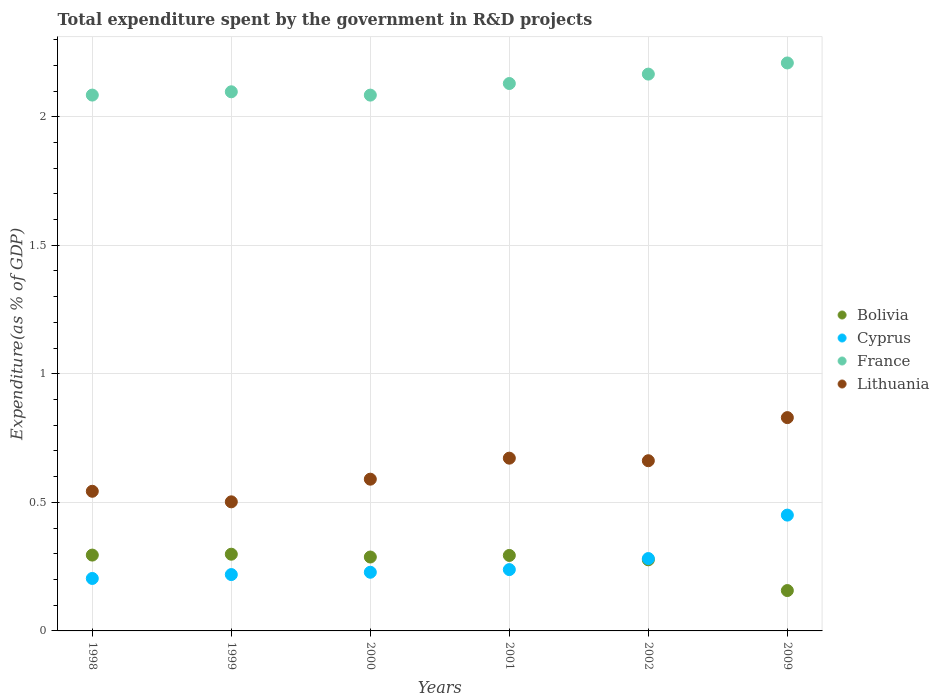Is the number of dotlines equal to the number of legend labels?
Your response must be concise. Yes. What is the total expenditure spent by the government in R&D projects in Bolivia in 2001?
Provide a succinct answer. 0.29. Across all years, what is the maximum total expenditure spent by the government in R&D projects in Bolivia?
Ensure brevity in your answer.  0.3. Across all years, what is the minimum total expenditure spent by the government in R&D projects in Lithuania?
Your answer should be compact. 0.5. What is the total total expenditure spent by the government in R&D projects in France in the graph?
Make the answer very short. 12.77. What is the difference between the total expenditure spent by the government in R&D projects in France in 1999 and that in 2002?
Provide a succinct answer. -0.07. What is the difference between the total expenditure spent by the government in R&D projects in Bolivia in 2001 and the total expenditure spent by the government in R&D projects in Lithuania in 2009?
Offer a terse response. -0.54. What is the average total expenditure spent by the government in R&D projects in France per year?
Provide a succinct answer. 2.13. In the year 1999, what is the difference between the total expenditure spent by the government in R&D projects in France and total expenditure spent by the government in R&D projects in Bolivia?
Make the answer very short. 1.8. What is the ratio of the total expenditure spent by the government in R&D projects in Lithuania in 1998 to that in 2000?
Keep it short and to the point. 0.92. Is the total expenditure spent by the government in R&D projects in Lithuania in 1999 less than that in 2001?
Your answer should be very brief. Yes. What is the difference between the highest and the second highest total expenditure spent by the government in R&D projects in Lithuania?
Your answer should be compact. 0.16. What is the difference between the highest and the lowest total expenditure spent by the government in R&D projects in Cyprus?
Provide a succinct answer. 0.25. In how many years, is the total expenditure spent by the government in R&D projects in France greater than the average total expenditure spent by the government in R&D projects in France taken over all years?
Keep it short and to the point. 3. Is the sum of the total expenditure spent by the government in R&D projects in Bolivia in 1998 and 2000 greater than the maximum total expenditure spent by the government in R&D projects in Cyprus across all years?
Provide a short and direct response. Yes. Is it the case that in every year, the sum of the total expenditure spent by the government in R&D projects in Cyprus and total expenditure spent by the government in R&D projects in Lithuania  is greater than the sum of total expenditure spent by the government in R&D projects in France and total expenditure spent by the government in R&D projects in Bolivia?
Give a very brief answer. Yes. Is the total expenditure spent by the government in R&D projects in Lithuania strictly less than the total expenditure spent by the government in R&D projects in Bolivia over the years?
Your response must be concise. No. How many years are there in the graph?
Keep it short and to the point. 6. What is the difference between two consecutive major ticks on the Y-axis?
Keep it short and to the point. 0.5. Does the graph contain any zero values?
Your answer should be compact. No. Does the graph contain grids?
Your answer should be compact. Yes. Where does the legend appear in the graph?
Offer a very short reply. Center right. What is the title of the graph?
Your answer should be very brief. Total expenditure spent by the government in R&D projects. What is the label or title of the X-axis?
Make the answer very short. Years. What is the label or title of the Y-axis?
Give a very brief answer. Expenditure(as % of GDP). What is the Expenditure(as % of GDP) of Bolivia in 1998?
Your answer should be very brief. 0.29. What is the Expenditure(as % of GDP) of Cyprus in 1998?
Offer a very short reply. 0.2. What is the Expenditure(as % of GDP) of France in 1998?
Your response must be concise. 2.08. What is the Expenditure(as % of GDP) in Lithuania in 1998?
Give a very brief answer. 0.54. What is the Expenditure(as % of GDP) of Bolivia in 1999?
Make the answer very short. 0.3. What is the Expenditure(as % of GDP) of Cyprus in 1999?
Your answer should be very brief. 0.22. What is the Expenditure(as % of GDP) of France in 1999?
Your response must be concise. 2.1. What is the Expenditure(as % of GDP) of Lithuania in 1999?
Ensure brevity in your answer.  0.5. What is the Expenditure(as % of GDP) of Bolivia in 2000?
Your answer should be compact. 0.29. What is the Expenditure(as % of GDP) of Cyprus in 2000?
Give a very brief answer. 0.23. What is the Expenditure(as % of GDP) in France in 2000?
Provide a short and direct response. 2.08. What is the Expenditure(as % of GDP) in Lithuania in 2000?
Your response must be concise. 0.59. What is the Expenditure(as % of GDP) of Bolivia in 2001?
Your answer should be very brief. 0.29. What is the Expenditure(as % of GDP) of Cyprus in 2001?
Keep it short and to the point. 0.24. What is the Expenditure(as % of GDP) of France in 2001?
Keep it short and to the point. 2.13. What is the Expenditure(as % of GDP) of Lithuania in 2001?
Provide a short and direct response. 0.67. What is the Expenditure(as % of GDP) in Bolivia in 2002?
Your answer should be compact. 0.28. What is the Expenditure(as % of GDP) in Cyprus in 2002?
Make the answer very short. 0.28. What is the Expenditure(as % of GDP) of France in 2002?
Give a very brief answer. 2.17. What is the Expenditure(as % of GDP) of Lithuania in 2002?
Provide a succinct answer. 0.66. What is the Expenditure(as % of GDP) of Bolivia in 2009?
Provide a short and direct response. 0.16. What is the Expenditure(as % of GDP) of Cyprus in 2009?
Provide a short and direct response. 0.45. What is the Expenditure(as % of GDP) in France in 2009?
Make the answer very short. 2.21. What is the Expenditure(as % of GDP) in Lithuania in 2009?
Ensure brevity in your answer.  0.83. Across all years, what is the maximum Expenditure(as % of GDP) of Bolivia?
Your answer should be compact. 0.3. Across all years, what is the maximum Expenditure(as % of GDP) of Cyprus?
Your answer should be compact. 0.45. Across all years, what is the maximum Expenditure(as % of GDP) of France?
Ensure brevity in your answer.  2.21. Across all years, what is the maximum Expenditure(as % of GDP) in Lithuania?
Your answer should be very brief. 0.83. Across all years, what is the minimum Expenditure(as % of GDP) of Bolivia?
Offer a terse response. 0.16. Across all years, what is the minimum Expenditure(as % of GDP) in Cyprus?
Give a very brief answer. 0.2. Across all years, what is the minimum Expenditure(as % of GDP) in France?
Ensure brevity in your answer.  2.08. Across all years, what is the minimum Expenditure(as % of GDP) in Lithuania?
Ensure brevity in your answer.  0.5. What is the total Expenditure(as % of GDP) of Bolivia in the graph?
Make the answer very short. 1.61. What is the total Expenditure(as % of GDP) of Cyprus in the graph?
Ensure brevity in your answer.  1.62. What is the total Expenditure(as % of GDP) in France in the graph?
Your response must be concise. 12.77. What is the total Expenditure(as % of GDP) in Lithuania in the graph?
Provide a short and direct response. 3.8. What is the difference between the Expenditure(as % of GDP) in Bolivia in 1998 and that in 1999?
Offer a terse response. -0. What is the difference between the Expenditure(as % of GDP) of Cyprus in 1998 and that in 1999?
Keep it short and to the point. -0.02. What is the difference between the Expenditure(as % of GDP) of France in 1998 and that in 1999?
Give a very brief answer. -0.01. What is the difference between the Expenditure(as % of GDP) of Lithuania in 1998 and that in 1999?
Your response must be concise. 0.04. What is the difference between the Expenditure(as % of GDP) of Bolivia in 1998 and that in 2000?
Your answer should be very brief. 0.01. What is the difference between the Expenditure(as % of GDP) in Cyprus in 1998 and that in 2000?
Provide a succinct answer. -0.02. What is the difference between the Expenditure(as % of GDP) in Lithuania in 1998 and that in 2000?
Keep it short and to the point. -0.05. What is the difference between the Expenditure(as % of GDP) of Bolivia in 1998 and that in 2001?
Your answer should be very brief. 0. What is the difference between the Expenditure(as % of GDP) of Cyprus in 1998 and that in 2001?
Keep it short and to the point. -0.03. What is the difference between the Expenditure(as % of GDP) in France in 1998 and that in 2001?
Provide a short and direct response. -0.04. What is the difference between the Expenditure(as % of GDP) of Lithuania in 1998 and that in 2001?
Keep it short and to the point. -0.13. What is the difference between the Expenditure(as % of GDP) in Bolivia in 1998 and that in 2002?
Your answer should be very brief. 0.02. What is the difference between the Expenditure(as % of GDP) in Cyprus in 1998 and that in 2002?
Provide a succinct answer. -0.08. What is the difference between the Expenditure(as % of GDP) in France in 1998 and that in 2002?
Provide a succinct answer. -0.08. What is the difference between the Expenditure(as % of GDP) of Lithuania in 1998 and that in 2002?
Offer a very short reply. -0.12. What is the difference between the Expenditure(as % of GDP) of Bolivia in 1998 and that in 2009?
Your response must be concise. 0.14. What is the difference between the Expenditure(as % of GDP) in Cyprus in 1998 and that in 2009?
Offer a very short reply. -0.25. What is the difference between the Expenditure(as % of GDP) in France in 1998 and that in 2009?
Your answer should be compact. -0.12. What is the difference between the Expenditure(as % of GDP) in Lithuania in 1998 and that in 2009?
Offer a very short reply. -0.29. What is the difference between the Expenditure(as % of GDP) of Bolivia in 1999 and that in 2000?
Provide a succinct answer. 0.01. What is the difference between the Expenditure(as % of GDP) of Cyprus in 1999 and that in 2000?
Your answer should be compact. -0.01. What is the difference between the Expenditure(as % of GDP) in France in 1999 and that in 2000?
Keep it short and to the point. 0.01. What is the difference between the Expenditure(as % of GDP) of Lithuania in 1999 and that in 2000?
Ensure brevity in your answer.  -0.09. What is the difference between the Expenditure(as % of GDP) of Bolivia in 1999 and that in 2001?
Give a very brief answer. 0. What is the difference between the Expenditure(as % of GDP) of Cyprus in 1999 and that in 2001?
Provide a succinct answer. -0.02. What is the difference between the Expenditure(as % of GDP) of France in 1999 and that in 2001?
Keep it short and to the point. -0.03. What is the difference between the Expenditure(as % of GDP) in Lithuania in 1999 and that in 2001?
Provide a short and direct response. -0.17. What is the difference between the Expenditure(as % of GDP) of Bolivia in 1999 and that in 2002?
Ensure brevity in your answer.  0.02. What is the difference between the Expenditure(as % of GDP) of Cyprus in 1999 and that in 2002?
Offer a very short reply. -0.06. What is the difference between the Expenditure(as % of GDP) of France in 1999 and that in 2002?
Make the answer very short. -0.07. What is the difference between the Expenditure(as % of GDP) of Lithuania in 1999 and that in 2002?
Your answer should be compact. -0.16. What is the difference between the Expenditure(as % of GDP) of Bolivia in 1999 and that in 2009?
Your answer should be compact. 0.14. What is the difference between the Expenditure(as % of GDP) in Cyprus in 1999 and that in 2009?
Provide a short and direct response. -0.23. What is the difference between the Expenditure(as % of GDP) of France in 1999 and that in 2009?
Provide a succinct answer. -0.11. What is the difference between the Expenditure(as % of GDP) of Lithuania in 1999 and that in 2009?
Keep it short and to the point. -0.33. What is the difference between the Expenditure(as % of GDP) in Bolivia in 2000 and that in 2001?
Provide a succinct answer. -0.01. What is the difference between the Expenditure(as % of GDP) in Cyprus in 2000 and that in 2001?
Provide a succinct answer. -0.01. What is the difference between the Expenditure(as % of GDP) in France in 2000 and that in 2001?
Your response must be concise. -0.05. What is the difference between the Expenditure(as % of GDP) in Lithuania in 2000 and that in 2001?
Make the answer very short. -0.08. What is the difference between the Expenditure(as % of GDP) in Bolivia in 2000 and that in 2002?
Make the answer very short. 0.01. What is the difference between the Expenditure(as % of GDP) of Cyprus in 2000 and that in 2002?
Your answer should be very brief. -0.05. What is the difference between the Expenditure(as % of GDP) of France in 2000 and that in 2002?
Give a very brief answer. -0.08. What is the difference between the Expenditure(as % of GDP) in Lithuania in 2000 and that in 2002?
Give a very brief answer. -0.07. What is the difference between the Expenditure(as % of GDP) in Bolivia in 2000 and that in 2009?
Your response must be concise. 0.13. What is the difference between the Expenditure(as % of GDP) in Cyprus in 2000 and that in 2009?
Provide a succinct answer. -0.22. What is the difference between the Expenditure(as % of GDP) in France in 2000 and that in 2009?
Keep it short and to the point. -0.13. What is the difference between the Expenditure(as % of GDP) of Lithuania in 2000 and that in 2009?
Your answer should be very brief. -0.24. What is the difference between the Expenditure(as % of GDP) of Bolivia in 2001 and that in 2002?
Ensure brevity in your answer.  0.02. What is the difference between the Expenditure(as % of GDP) of Cyprus in 2001 and that in 2002?
Ensure brevity in your answer.  -0.04. What is the difference between the Expenditure(as % of GDP) of France in 2001 and that in 2002?
Make the answer very short. -0.04. What is the difference between the Expenditure(as % of GDP) in Lithuania in 2001 and that in 2002?
Offer a very short reply. 0.01. What is the difference between the Expenditure(as % of GDP) of Bolivia in 2001 and that in 2009?
Your answer should be very brief. 0.14. What is the difference between the Expenditure(as % of GDP) of Cyprus in 2001 and that in 2009?
Make the answer very short. -0.21. What is the difference between the Expenditure(as % of GDP) in France in 2001 and that in 2009?
Your response must be concise. -0.08. What is the difference between the Expenditure(as % of GDP) in Lithuania in 2001 and that in 2009?
Make the answer very short. -0.16. What is the difference between the Expenditure(as % of GDP) of Bolivia in 2002 and that in 2009?
Your response must be concise. 0.12. What is the difference between the Expenditure(as % of GDP) of Cyprus in 2002 and that in 2009?
Provide a short and direct response. -0.17. What is the difference between the Expenditure(as % of GDP) in France in 2002 and that in 2009?
Ensure brevity in your answer.  -0.04. What is the difference between the Expenditure(as % of GDP) of Lithuania in 2002 and that in 2009?
Your answer should be very brief. -0.17. What is the difference between the Expenditure(as % of GDP) of Bolivia in 1998 and the Expenditure(as % of GDP) of Cyprus in 1999?
Ensure brevity in your answer.  0.08. What is the difference between the Expenditure(as % of GDP) in Bolivia in 1998 and the Expenditure(as % of GDP) in France in 1999?
Your answer should be very brief. -1.8. What is the difference between the Expenditure(as % of GDP) of Bolivia in 1998 and the Expenditure(as % of GDP) of Lithuania in 1999?
Give a very brief answer. -0.21. What is the difference between the Expenditure(as % of GDP) of Cyprus in 1998 and the Expenditure(as % of GDP) of France in 1999?
Make the answer very short. -1.89. What is the difference between the Expenditure(as % of GDP) in Cyprus in 1998 and the Expenditure(as % of GDP) in Lithuania in 1999?
Provide a succinct answer. -0.3. What is the difference between the Expenditure(as % of GDP) in France in 1998 and the Expenditure(as % of GDP) in Lithuania in 1999?
Your answer should be compact. 1.58. What is the difference between the Expenditure(as % of GDP) in Bolivia in 1998 and the Expenditure(as % of GDP) in Cyprus in 2000?
Offer a very short reply. 0.07. What is the difference between the Expenditure(as % of GDP) of Bolivia in 1998 and the Expenditure(as % of GDP) of France in 2000?
Make the answer very short. -1.79. What is the difference between the Expenditure(as % of GDP) in Bolivia in 1998 and the Expenditure(as % of GDP) in Lithuania in 2000?
Offer a terse response. -0.3. What is the difference between the Expenditure(as % of GDP) of Cyprus in 1998 and the Expenditure(as % of GDP) of France in 2000?
Your response must be concise. -1.88. What is the difference between the Expenditure(as % of GDP) in Cyprus in 1998 and the Expenditure(as % of GDP) in Lithuania in 2000?
Your answer should be compact. -0.39. What is the difference between the Expenditure(as % of GDP) in France in 1998 and the Expenditure(as % of GDP) in Lithuania in 2000?
Ensure brevity in your answer.  1.49. What is the difference between the Expenditure(as % of GDP) in Bolivia in 1998 and the Expenditure(as % of GDP) in Cyprus in 2001?
Your response must be concise. 0.06. What is the difference between the Expenditure(as % of GDP) of Bolivia in 1998 and the Expenditure(as % of GDP) of France in 2001?
Keep it short and to the point. -1.83. What is the difference between the Expenditure(as % of GDP) in Bolivia in 1998 and the Expenditure(as % of GDP) in Lithuania in 2001?
Provide a succinct answer. -0.38. What is the difference between the Expenditure(as % of GDP) of Cyprus in 1998 and the Expenditure(as % of GDP) of France in 2001?
Offer a terse response. -1.93. What is the difference between the Expenditure(as % of GDP) of Cyprus in 1998 and the Expenditure(as % of GDP) of Lithuania in 2001?
Offer a very short reply. -0.47. What is the difference between the Expenditure(as % of GDP) of France in 1998 and the Expenditure(as % of GDP) of Lithuania in 2001?
Your response must be concise. 1.41. What is the difference between the Expenditure(as % of GDP) of Bolivia in 1998 and the Expenditure(as % of GDP) of Cyprus in 2002?
Your response must be concise. 0.01. What is the difference between the Expenditure(as % of GDP) of Bolivia in 1998 and the Expenditure(as % of GDP) of France in 2002?
Your answer should be very brief. -1.87. What is the difference between the Expenditure(as % of GDP) in Bolivia in 1998 and the Expenditure(as % of GDP) in Lithuania in 2002?
Your answer should be very brief. -0.37. What is the difference between the Expenditure(as % of GDP) in Cyprus in 1998 and the Expenditure(as % of GDP) in France in 2002?
Make the answer very short. -1.96. What is the difference between the Expenditure(as % of GDP) of Cyprus in 1998 and the Expenditure(as % of GDP) of Lithuania in 2002?
Keep it short and to the point. -0.46. What is the difference between the Expenditure(as % of GDP) of France in 1998 and the Expenditure(as % of GDP) of Lithuania in 2002?
Keep it short and to the point. 1.42. What is the difference between the Expenditure(as % of GDP) of Bolivia in 1998 and the Expenditure(as % of GDP) of Cyprus in 2009?
Make the answer very short. -0.16. What is the difference between the Expenditure(as % of GDP) in Bolivia in 1998 and the Expenditure(as % of GDP) in France in 2009?
Your response must be concise. -1.91. What is the difference between the Expenditure(as % of GDP) of Bolivia in 1998 and the Expenditure(as % of GDP) of Lithuania in 2009?
Provide a short and direct response. -0.53. What is the difference between the Expenditure(as % of GDP) in Cyprus in 1998 and the Expenditure(as % of GDP) in France in 2009?
Offer a very short reply. -2. What is the difference between the Expenditure(as % of GDP) of Cyprus in 1998 and the Expenditure(as % of GDP) of Lithuania in 2009?
Your answer should be compact. -0.63. What is the difference between the Expenditure(as % of GDP) in France in 1998 and the Expenditure(as % of GDP) in Lithuania in 2009?
Make the answer very short. 1.25. What is the difference between the Expenditure(as % of GDP) in Bolivia in 1999 and the Expenditure(as % of GDP) in Cyprus in 2000?
Keep it short and to the point. 0.07. What is the difference between the Expenditure(as % of GDP) of Bolivia in 1999 and the Expenditure(as % of GDP) of France in 2000?
Offer a terse response. -1.79. What is the difference between the Expenditure(as % of GDP) in Bolivia in 1999 and the Expenditure(as % of GDP) in Lithuania in 2000?
Your answer should be compact. -0.29. What is the difference between the Expenditure(as % of GDP) in Cyprus in 1999 and the Expenditure(as % of GDP) in France in 2000?
Give a very brief answer. -1.86. What is the difference between the Expenditure(as % of GDP) of Cyprus in 1999 and the Expenditure(as % of GDP) of Lithuania in 2000?
Give a very brief answer. -0.37. What is the difference between the Expenditure(as % of GDP) of France in 1999 and the Expenditure(as % of GDP) of Lithuania in 2000?
Your answer should be compact. 1.51. What is the difference between the Expenditure(as % of GDP) of Bolivia in 1999 and the Expenditure(as % of GDP) of Cyprus in 2001?
Give a very brief answer. 0.06. What is the difference between the Expenditure(as % of GDP) in Bolivia in 1999 and the Expenditure(as % of GDP) in France in 2001?
Keep it short and to the point. -1.83. What is the difference between the Expenditure(as % of GDP) in Bolivia in 1999 and the Expenditure(as % of GDP) in Lithuania in 2001?
Keep it short and to the point. -0.37. What is the difference between the Expenditure(as % of GDP) of Cyprus in 1999 and the Expenditure(as % of GDP) of France in 2001?
Offer a terse response. -1.91. What is the difference between the Expenditure(as % of GDP) in Cyprus in 1999 and the Expenditure(as % of GDP) in Lithuania in 2001?
Give a very brief answer. -0.45. What is the difference between the Expenditure(as % of GDP) of France in 1999 and the Expenditure(as % of GDP) of Lithuania in 2001?
Offer a terse response. 1.43. What is the difference between the Expenditure(as % of GDP) of Bolivia in 1999 and the Expenditure(as % of GDP) of Cyprus in 2002?
Your answer should be very brief. 0.02. What is the difference between the Expenditure(as % of GDP) in Bolivia in 1999 and the Expenditure(as % of GDP) in France in 2002?
Your response must be concise. -1.87. What is the difference between the Expenditure(as % of GDP) in Bolivia in 1999 and the Expenditure(as % of GDP) in Lithuania in 2002?
Ensure brevity in your answer.  -0.36. What is the difference between the Expenditure(as % of GDP) of Cyprus in 1999 and the Expenditure(as % of GDP) of France in 2002?
Make the answer very short. -1.95. What is the difference between the Expenditure(as % of GDP) in Cyprus in 1999 and the Expenditure(as % of GDP) in Lithuania in 2002?
Your answer should be compact. -0.44. What is the difference between the Expenditure(as % of GDP) in France in 1999 and the Expenditure(as % of GDP) in Lithuania in 2002?
Provide a short and direct response. 1.44. What is the difference between the Expenditure(as % of GDP) of Bolivia in 1999 and the Expenditure(as % of GDP) of Cyprus in 2009?
Your response must be concise. -0.15. What is the difference between the Expenditure(as % of GDP) in Bolivia in 1999 and the Expenditure(as % of GDP) in France in 2009?
Your response must be concise. -1.91. What is the difference between the Expenditure(as % of GDP) in Bolivia in 1999 and the Expenditure(as % of GDP) in Lithuania in 2009?
Offer a very short reply. -0.53. What is the difference between the Expenditure(as % of GDP) of Cyprus in 1999 and the Expenditure(as % of GDP) of France in 2009?
Your answer should be very brief. -1.99. What is the difference between the Expenditure(as % of GDP) in Cyprus in 1999 and the Expenditure(as % of GDP) in Lithuania in 2009?
Make the answer very short. -0.61. What is the difference between the Expenditure(as % of GDP) of France in 1999 and the Expenditure(as % of GDP) of Lithuania in 2009?
Offer a terse response. 1.27. What is the difference between the Expenditure(as % of GDP) of Bolivia in 2000 and the Expenditure(as % of GDP) of Cyprus in 2001?
Offer a terse response. 0.05. What is the difference between the Expenditure(as % of GDP) in Bolivia in 2000 and the Expenditure(as % of GDP) in France in 2001?
Your answer should be compact. -1.84. What is the difference between the Expenditure(as % of GDP) in Bolivia in 2000 and the Expenditure(as % of GDP) in Lithuania in 2001?
Give a very brief answer. -0.38. What is the difference between the Expenditure(as % of GDP) of Cyprus in 2000 and the Expenditure(as % of GDP) of France in 2001?
Your answer should be compact. -1.9. What is the difference between the Expenditure(as % of GDP) of Cyprus in 2000 and the Expenditure(as % of GDP) of Lithuania in 2001?
Your response must be concise. -0.44. What is the difference between the Expenditure(as % of GDP) in France in 2000 and the Expenditure(as % of GDP) in Lithuania in 2001?
Offer a very short reply. 1.41. What is the difference between the Expenditure(as % of GDP) of Bolivia in 2000 and the Expenditure(as % of GDP) of Cyprus in 2002?
Your response must be concise. 0.01. What is the difference between the Expenditure(as % of GDP) in Bolivia in 2000 and the Expenditure(as % of GDP) in France in 2002?
Give a very brief answer. -1.88. What is the difference between the Expenditure(as % of GDP) of Bolivia in 2000 and the Expenditure(as % of GDP) of Lithuania in 2002?
Give a very brief answer. -0.37. What is the difference between the Expenditure(as % of GDP) of Cyprus in 2000 and the Expenditure(as % of GDP) of France in 2002?
Make the answer very short. -1.94. What is the difference between the Expenditure(as % of GDP) in Cyprus in 2000 and the Expenditure(as % of GDP) in Lithuania in 2002?
Give a very brief answer. -0.43. What is the difference between the Expenditure(as % of GDP) in France in 2000 and the Expenditure(as % of GDP) in Lithuania in 2002?
Provide a succinct answer. 1.42. What is the difference between the Expenditure(as % of GDP) of Bolivia in 2000 and the Expenditure(as % of GDP) of Cyprus in 2009?
Your answer should be very brief. -0.16. What is the difference between the Expenditure(as % of GDP) of Bolivia in 2000 and the Expenditure(as % of GDP) of France in 2009?
Make the answer very short. -1.92. What is the difference between the Expenditure(as % of GDP) in Bolivia in 2000 and the Expenditure(as % of GDP) in Lithuania in 2009?
Provide a succinct answer. -0.54. What is the difference between the Expenditure(as % of GDP) of Cyprus in 2000 and the Expenditure(as % of GDP) of France in 2009?
Provide a succinct answer. -1.98. What is the difference between the Expenditure(as % of GDP) of Cyprus in 2000 and the Expenditure(as % of GDP) of Lithuania in 2009?
Your answer should be very brief. -0.6. What is the difference between the Expenditure(as % of GDP) of France in 2000 and the Expenditure(as % of GDP) of Lithuania in 2009?
Give a very brief answer. 1.25. What is the difference between the Expenditure(as % of GDP) of Bolivia in 2001 and the Expenditure(as % of GDP) of Cyprus in 2002?
Provide a short and direct response. 0.01. What is the difference between the Expenditure(as % of GDP) in Bolivia in 2001 and the Expenditure(as % of GDP) in France in 2002?
Give a very brief answer. -1.87. What is the difference between the Expenditure(as % of GDP) of Bolivia in 2001 and the Expenditure(as % of GDP) of Lithuania in 2002?
Provide a succinct answer. -0.37. What is the difference between the Expenditure(as % of GDP) of Cyprus in 2001 and the Expenditure(as % of GDP) of France in 2002?
Offer a terse response. -1.93. What is the difference between the Expenditure(as % of GDP) of Cyprus in 2001 and the Expenditure(as % of GDP) of Lithuania in 2002?
Give a very brief answer. -0.42. What is the difference between the Expenditure(as % of GDP) of France in 2001 and the Expenditure(as % of GDP) of Lithuania in 2002?
Your response must be concise. 1.47. What is the difference between the Expenditure(as % of GDP) of Bolivia in 2001 and the Expenditure(as % of GDP) of Cyprus in 2009?
Give a very brief answer. -0.16. What is the difference between the Expenditure(as % of GDP) in Bolivia in 2001 and the Expenditure(as % of GDP) in France in 2009?
Your response must be concise. -1.92. What is the difference between the Expenditure(as % of GDP) in Bolivia in 2001 and the Expenditure(as % of GDP) in Lithuania in 2009?
Provide a short and direct response. -0.54. What is the difference between the Expenditure(as % of GDP) in Cyprus in 2001 and the Expenditure(as % of GDP) in France in 2009?
Offer a very short reply. -1.97. What is the difference between the Expenditure(as % of GDP) of Cyprus in 2001 and the Expenditure(as % of GDP) of Lithuania in 2009?
Your answer should be very brief. -0.59. What is the difference between the Expenditure(as % of GDP) of France in 2001 and the Expenditure(as % of GDP) of Lithuania in 2009?
Provide a succinct answer. 1.3. What is the difference between the Expenditure(as % of GDP) of Bolivia in 2002 and the Expenditure(as % of GDP) of Cyprus in 2009?
Offer a terse response. -0.17. What is the difference between the Expenditure(as % of GDP) in Bolivia in 2002 and the Expenditure(as % of GDP) in France in 2009?
Provide a short and direct response. -1.93. What is the difference between the Expenditure(as % of GDP) of Bolivia in 2002 and the Expenditure(as % of GDP) of Lithuania in 2009?
Your response must be concise. -0.55. What is the difference between the Expenditure(as % of GDP) in Cyprus in 2002 and the Expenditure(as % of GDP) in France in 2009?
Your response must be concise. -1.93. What is the difference between the Expenditure(as % of GDP) of Cyprus in 2002 and the Expenditure(as % of GDP) of Lithuania in 2009?
Make the answer very short. -0.55. What is the difference between the Expenditure(as % of GDP) in France in 2002 and the Expenditure(as % of GDP) in Lithuania in 2009?
Give a very brief answer. 1.34. What is the average Expenditure(as % of GDP) of Bolivia per year?
Provide a short and direct response. 0.27. What is the average Expenditure(as % of GDP) in Cyprus per year?
Offer a terse response. 0.27. What is the average Expenditure(as % of GDP) in France per year?
Your answer should be very brief. 2.13. What is the average Expenditure(as % of GDP) of Lithuania per year?
Offer a very short reply. 0.63. In the year 1998, what is the difference between the Expenditure(as % of GDP) of Bolivia and Expenditure(as % of GDP) of Cyprus?
Give a very brief answer. 0.09. In the year 1998, what is the difference between the Expenditure(as % of GDP) in Bolivia and Expenditure(as % of GDP) in France?
Provide a short and direct response. -1.79. In the year 1998, what is the difference between the Expenditure(as % of GDP) in Bolivia and Expenditure(as % of GDP) in Lithuania?
Offer a very short reply. -0.25. In the year 1998, what is the difference between the Expenditure(as % of GDP) of Cyprus and Expenditure(as % of GDP) of France?
Your answer should be very brief. -1.88. In the year 1998, what is the difference between the Expenditure(as % of GDP) in Cyprus and Expenditure(as % of GDP) in Lithuania?
Provide a succinct answer. -0.34. In the year 1998, what is the difference between the Expenditure(as % of GDP) of France and Expenditure(as % of GDP) of Lithuania?
Give a very brief answer. 1.54. In the year 1999, what is the difference between the Expenditure(as % of GDP) in Bolivia and Expenditure(as % of GDP) in Cyprus?
Your response must be concise. 0.08. In the year 1999, what is the difference between the Expenditure(as % of GDP) of Bolivia and Expenditure(as % of GDP) of France?
Your answer should be compact. -1.8. In the year 1999, what is the difference between the Expenditure(as % of GDP) in Bolivia and Expenditure(as % of GDP) in Lithuania?
Your response must be concise. -0.2. In the year 1999, what is the difference between the Expenditure(as % of GDP) in Cyprus and Expenditure(as % of GDP) in France?
Offer a very short reply. -1.88. In the year 1999, what is the difference between the Expenditure(as % of GDP) of Cyprus and Expenditure(as % of GDP) of Lithuania?
Provide a succinct answer. -0.28. In the year 1999, what is the difference between the Expenditure(as % of GDP) in France and Expenditure(as % of GDP) in Lithuania?
Your answer should be compact. 1.59. In the year 2000, what is the difference between the Expenditure(as % of GDP) in Bolivia and Expenditure(as % of GDP) in Cyprus?
Your answer should be very brief. 0.06. In the year 2000, what is the difference between the Expenditure(as % of GDP) in Bolivia and Expenditure(as % of GDP) in France?
Give a very brief answer. -1.8. In the year 2000, what is the difference between the Expenditure(as % of GDP) in Bolivia and Expenditure(as % of GDP) in Lithuania?
Keep it short and to the point. -0.3. In the year 2000, what is the difference between the Expenditure(as % of GDP) of Cyprus and Expenditure(as % of GDP) of France?
Give a very brief answer. -1.86. In the year 2000, what is the difference between the Expenditure(as % of GDP) in Cyprus and Expenditure(as % of GDP) in Lithuania?
Ensure brevity in your answer.  -0.36. In the year 2000, what is the difference between the Expenditure(as % of GDP) in France and Expenditure(as % of GDP) in Lithuania?
Keep it short and to the point. 1.49. In the year 2001, what is the difference between the Expenditure(as % of GDP) in Bolivia and Expenditure(as % of GDP) in Cyprus?
Your answer should be very brief. 0.06. In the year 2001, what is the difference between the Expenditure(as % of GDP) in Bolivia and Expenditure(as % of GDP) in France?
Keep it short and to the point. -1.84. In the year 2001, what is the difference between the Expenditure(as % of GDP) in Bolivia and Expenditure(as % of GDP) in Lithuania?
Give a very brief answer. -0.38. In the year 2001, what is the difference between the Expenditure(as % of GDP) in Cyprus and Expenditure(as % of GDP) in France?
Provide a short and direct response. -1.89. In the year 2001, what is the difference between the Expenditure(as % of GDP) in Cyprus and Expenditure(as % of GDP) in Lithuania?
Offer a very short reply. -0.43. In the year 2001, what is the difference between the Expenditure(as % of GDP) of France and Expenditure(as % of GDP) of Lithuania?
Your answer should be compact. 1.46. In the year 2002, what is the difference between the Expenditure(as % of GDP) in Bolivia and Expenditure(as % of GDP) in Cyprus?
Give a very brief answer. -0. In the year 2002, what is the difference between the Expenditure(as % of GDP) in Bolivia and Expenditure(as % of GDP) in France?
Make the answer very short. -1.89. In the year 2002, what is the difference between the Expenditure(as % of GDP) of Bolivia and Expenditure(as % of GDP) of Lithuania?
Your response must be concise. -0.39. In the year 2002, what is the difference between the Expenditure(as % of GDP) of Cyprus and Expenditure(as % of GDP) of France?
Ensure brevity in your answer.  -1.88. In the year 2002, what is the difference between the Expenditure(as % of GDP) of Cyprus and Expenditure(as % of GDP) of Lithuania?
Your answer should be very brief. -0.38. In the year 2002, what is the difference between the Expenditure(as % of GDP) of France and Expenditure(as % of GDP) of Lithuania?
Give a very brief answer. 1.5. In the year 2009, what is the difference between the Expenditure(as % of GDP) in Bolivia and Expenditure(as % of GDP) in Cyprus?
Your answer should be very brief. -0.29. In the year 2009, what is the difference between the Expenditure(as % of GDP) of Bolivia and Expenditure(as % of GDP) of France?
Your answer should be very brief. -2.05. In the year 2009, what is the difference between the Expenditure(as % of GDP) of Bolivia and Expenditure(as % of GDP) of Lithuania?
Offer a very short reply. -0.67. In the year 2009, what is the difference between the Expenditure(as % of GDP) of Cyprus and Expenditure(as % of GDP) of France?
Provide a succinct answer. -1.76. In the year 2009, what is the difference between the Expenditure(as % of GDP) of Cyprus and Expenditure(as % of GDP) of Lithuania?
Give a very brief answer. -0.38. In the year 2009, what is the difference between the Expenditure(as % of GDP) in France and Expenditure(as % of GDP) in Lithuania?
Your answer should be compact. 1.38. What is the ratio of the Expenditure(as % of GDP) of Bolivia in 1998 to that in 1999?
Your response must be concise. 0.99. What is the ratio of the Expenditure(as % of GDP) of Cyprus in 1998 to that in 1999?
Keep it short and to the point. 0.93. What is the ratio of the Expenditure(as % of GDP) of Lithuania in 1998 to that in 1999?
Make the answer very short. 1.08. What is the ratio of the Expenditure(as % of GDP) of Bolivia in 1998 to that in 2000?
Your answer should be very brief. 1.03. What is the ratio of the Expenditure(as % of GDP) of Cyprus in 1998 to that in 2000?
Offer a terse response. 0.89. What is the ratio of the Expenditure(as % of GDP) in Lithuania in 1998 to that in 2000?
Your answer should be compact. 0.92. What is the ratio of the Expenditure(as % of GDP) of Cyprus in 1998 to that in 2001?
Your response must be concise. 0.86. What is the ratio of the Expenditure(as % of GDP) in France in 1998 to that in 2001?
Provide a short and direct response. 0.98. What is the ratio of the Expenditure(as % of GDP) in Lithuania in 1998 to that in 2001?
Offer a very short reply. 0.81. What is the ratio of the Expenditure(as % of GDP) of Bolivia in 1998 to that in 2002?
Ensure brevity in your answer.  1.07. What is the ratio of the Expenditure(as % of GDP) in Cyprus in 1998 to that in 2002?
Keep it short and to the point. 0.72. What is the ratio of the Expenditure(as % of GDP) of France in 1998 to that in 2002?
Your response must be concise. 0.96. What is the ratio of the Expenditure(as % of GDP) in Lithuania in 1998 to that in 2002?
Your answer should be very brief. 0.82. What is the ratio of the Expenditure(as % of GDP) in Bolivia in 1998 to that in 2009?
Provide a short and direct response. 1.88. What is the ratio of the Expenditure(as % of GDP) of Cyprus in 1998 to that in 2009?
Keep it short and to the point. 0.45. What is the ratio of the Expenditure(as % of GDP) of France in 1998 to that in 2009?
Your answer should be compact. 0.94. What is the ratio of the Expenditure(as % of GDP) in Lithuania in 1998 to that in 2009?
Keep it short and to the point. 0.65. What is the ratio of the Expenditure(as % of GDP) in Bolivia in 1999 to that in 2000?
Your response must be concise. 1.04. What is the ratio of the Expenditure(as % of GDP) of Cyprus in 1999 to that in 2000?
Your answer should be compact. 0.96. What is the ratio of the Expenditure(as % of GDP) in France in 1999 to that in 2000?
Offer a terse response. 1.01. What is the ratio of the Expenditure(as % of GDP) of Lithuania in 1999 to that in 2000?
Your answer should be very brief. 0.85. What is the ratio of the Expenditure(as % of GDP) of Bolivia in 1999 to that in 2001?
Offer a very short reply. 1.02. What is the ratio of the Expenditure(as % of GDP) in Cyprus in 1999 to that in 2001?
Offer a terse response. 0.92. What is the ratio of the Expenditure(as % of GDP) of France in 1999 to that in 2001?
Give a very brief answer. 0.98. What is the ratio of the Expenditure(as % of GDP) of Lithuania in 1999 to that in 2001?
Your response must be concise. 0.75. What is the ratio of the Expenditure(as % of GDP) in Bolivia in 1999 to that in 2002?
Make the answer very short. 1.08. What is the ratio of the Expenditure(as % of GDP) in Cyprus in 1999 to that in 2002?
Provide a succinct answer. 0.78. What is the ratio of the Expenditure(as % of GDP) in France in 1999 to that in 2002?
Offer a very short reply. 0.97. What is the ratio of the Expenditure(as % of GDP) in Lithuania in 1999 to that in 2002?
Give a very brief answer. 0.76. What is the ratio of the Expenditure(as % of GDP) of Bolivia in 1999 to that in 2009?
Make the answer very short. 1.9. What is the ratio of the Expenditure(as % of GDP) of Cyprus in 1999 to that in 2009?
Provide a short and direct response. 0.49. What is the ratio of the Expenditure(as % of GDP) of France in 1999 to that in 2009?
Your response must be concise. 0.95. What is the ratio of the Expenditure(as % of GDP) of Lithuania in 1999 to that in 2009?
Offer a very short reply. 0.61. What is the ratio of the Expenditure(as % of GDP) in Bolivia in 2000 to that in 2001?
Provide a short and direct response. 0.98. What is the ratio of the Expenditure(as % of GDP) of Cyprus in 2000 to that in 2001?
Provide a short and direct response. 0.96. What is the ratio of the Expenditure(as % of GDP) in France in 2000 to that in 2001?
Your response must be concise. 0.98. What is the ratio of the Expenditure(as % of GDP) of Lithuania in 2000 to that in 2001?
Give a very brief answer. 0.88. What is the ratio of the Expenditure(as % of GDP) in Bolivia in 2000 to that in 2002?
Give a very brief answer. 1.04. What is the ratio of the Expenditure(as % of GDP) in Cyprus in 2000 to that in 2002?
Ensure brevity in your answer.  0.81. What is the ratio of the Expenditure(as % of GDP) in France in 2000 to that in 2002?
Make the answer very short. 0.96. What is the ratio of the Expenditure(as % of GDP) of Lithuania in 2000 to that in 2002?
Keep it short and to the point. 0.89. What is the ratio of the Expenditure(as % of GDP) in Bolivia in 2000 to that in 2009?
Your answer should be very brief. 1.83. What is the ratio of the Expenditure(as % of GDP) in Cyprus in 2000 to that in 2009?
Keep it short and to the point. 0.51. What is the ratio of the Expenditure(as % of GDP) in France in 2000 to that in 2009?
Ensure brevity in your answer.  0.94. What is the ratio of the Expenditure(as % of GDP) in Lithuania in 2000 to that in 2009?
Give a very brief answer. 0.71. What is the ratio of the Expenditure(as % of GDP) of Bolivia in 2001 to that in 2002?
Your response must be concise. 1.06. What is the ratio of the Expenditure(as % of GDP) of Cyprus in 2001 to that in 2002?
Your response must be concise. 0.85. What is the ratio of the Expenditure(as % of GDP) in France in 2001 to that in 2002?
Give a very brief answer. 0.98. What is the ratio of the Expenditure(as % of GDP) of Lithuania in 2001 to that in 2002?
Keep it short and to the point. 1.01. What is the ratio of the Expenditure(as % of GDP) of Bolivia in 2001 to that in 2009?
Provide a short and direct response. 1.87. What is the ratio of the Expenditure(as % of GDP) of Cyprus in 2001 to that in 2009?
Make the answer very short. 0.53. What is the ratio of the Expenditure(as % of GDP) in France in 2001 to that in 2009?
Provide a short and direct response. 0.96. What is the ratio of the Expenditure(as % of GDP) of Lithuania in 2001 to that in 2009?
Make the answer very short. 0.81. What is the ratio of the Expenditure(as % of GDP) in Bolivia in 2002 to that in 2009?
Your answer should be compact. 1.76. What is the ratio of the Expenditure(as % of GDP) in Cyprus in 2002 to that in 2009?
Ensure brevity in your answer.  0.62. What is the ratio of the Expenditure(as % of GDP) of France in 2002 to that in 2009?
Provide a short and direct response. 0.98. What is the ratio of the Expenditure(as % of GDP) of Lithuania in 2002 to that in 2009?
Provide a short and direct response. 0.8. What is the difference between the highest and the second highest Expenditure(as % of GDP) of Bolivia?
Offer a very short reply. 0. What is the difference between the highest and the second highest Expenditure(as % of GDP) in Cyprus?
Keep it short and to the point. 0.17. What is the difference between the highest and the second highest Expenditure(as % of GDP) in France?
Provide a short and direct response. 0.04. What is the difference between the highest and the second highest Expenditure(as % of GDP) in Lithuania?
Provide a short and direct response. 0.16. What is the difference between the highest and the lowest Expenditure(as % of GDP) of Bolivia?
Give a very brief answer. 0.14. What is the difference between the highest and the lowest Expenditure(as % of GDP) in Cyprus?
Give a very brief answer. 0.25. What is the difference between the highest and the lowest Expenditure(as % of GDP) of France?
Keep it short and to the point. 0.13. What is the difference between the highest and the lowest Expenditure(as % of GDP) of Lithuania?
Offer a terse response. 0.33. 